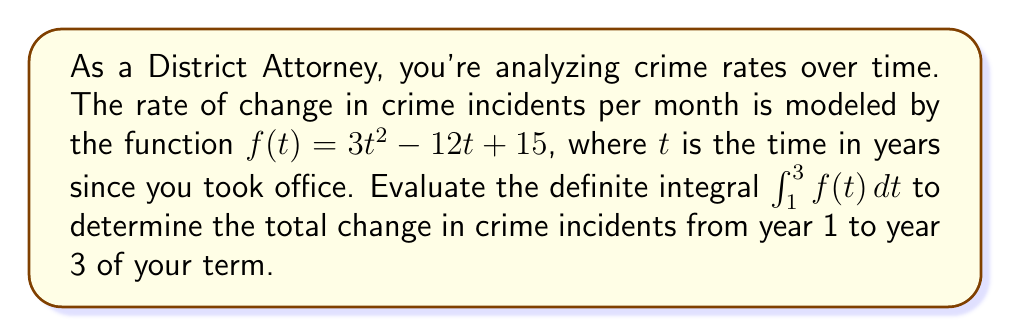Help me with this question. To solve this problem, we'll use the Fundamental Theorem of Calculus. Let's break it down step-by-step:

1) The Fundamental Theorem of Calculus states that if $F(t)$ is an antiderivative of $f(t)$, then:

   $$\int_a^b f(t) dt = F(b) - F(a)$$

2) First, we need to find an antiderivative $F(t)$ of $f(t) = 3t^2 - 12t + 15$:

   $$F(t) = t^3 - 6t^2 + 15t + C$$

3) Now, we can apply the Fundamental Theorem of Calculus:

   $$\int_1^3 f(t) dt = F(3) - F(1)$$

4) Let's calculate $F(3)$ and $F(1)$:

   $F(3) = 3^3 - 6(3^2) + 15(3) + C = 27 - 54 + 45 + C = 18 + C$
   
   $F(1) = 1^3 - 6(1^2) + 15(1) + C = 1 - 6 + 15 + C = 10 + C$

5) Now we can subtract:

   $$F(3) - F(1) = (18 + C) - (10 + C) = 18 - 10 = 8$$

6) Therefore, the total change in crime incidents from year 1 to year 3 is 8.

This result indicates that, despite fluctuations in the rate of change, there was a net increase of 8 crime incidents over this two-year period.
Answer: 8 crime incidents 